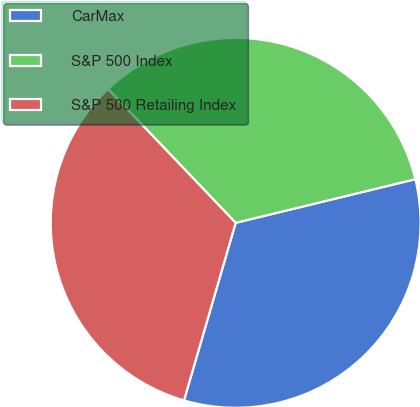Convert chart to OTSL. <chart><loc_0><loc_0><loc_500><loc_500><pie_chart><fcel>CarMax<fcel>S&P 500 Index<fcel>S&P 500 Retailing Index<nl><fcel>33.3%<fcel>33.33%<fcel>33.37%<nl></chart> 